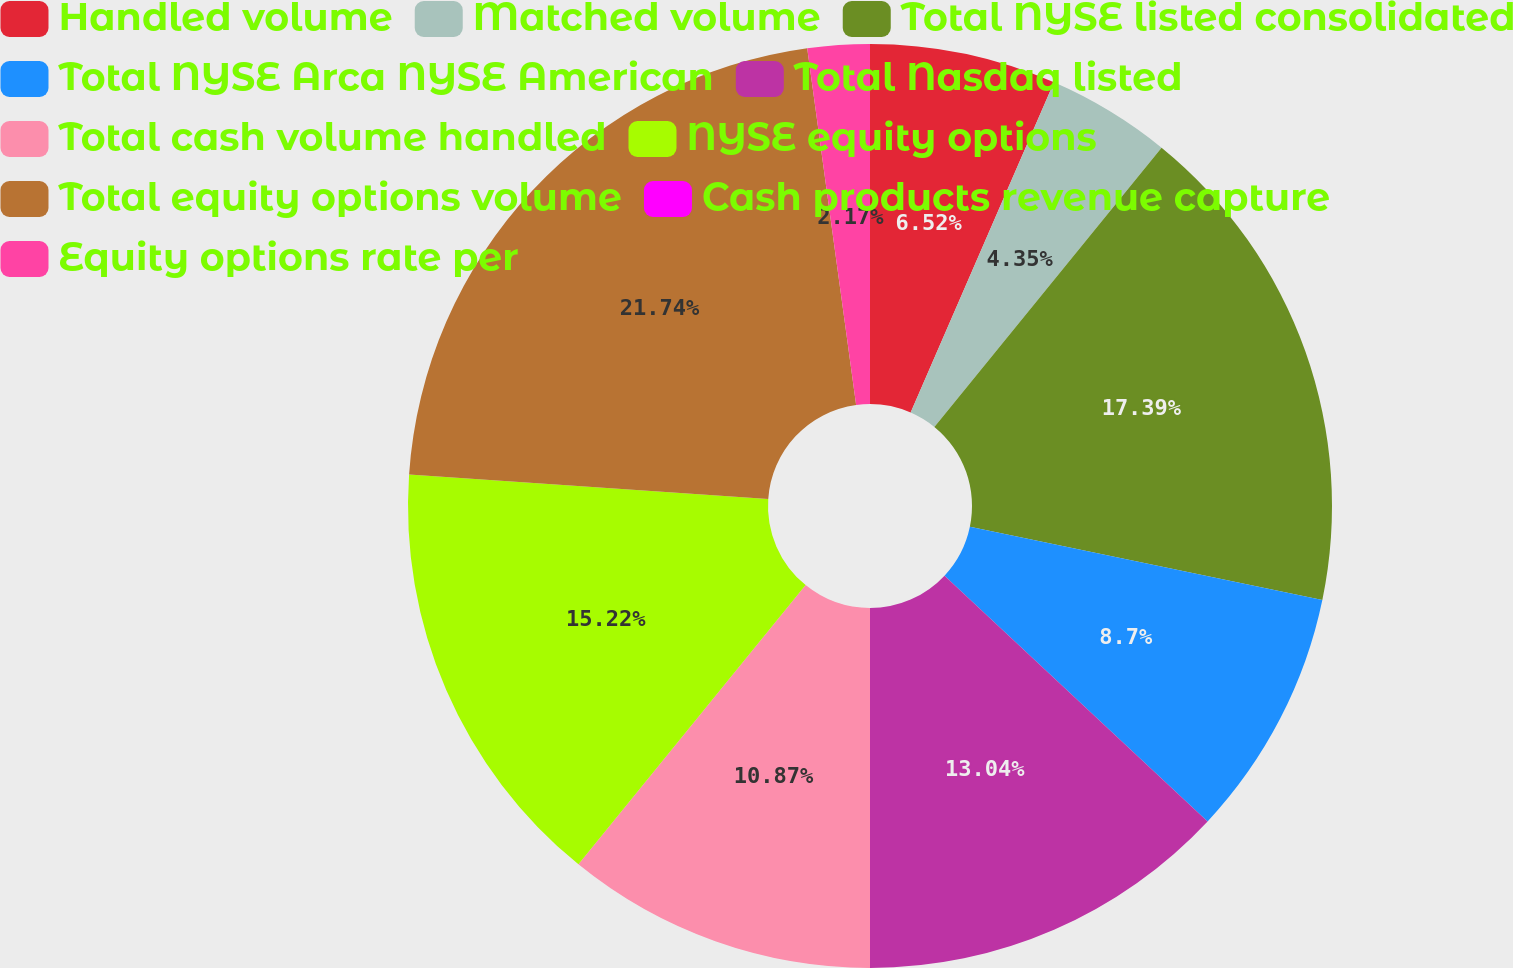Convert chart. <chart><loc_0><loc_0><loc_500><loc_500><pie_chart><fcel>Handled volume<fcel>Matched volume<fcel>Total NYSE listed consolidated<fcel>Total NYSE Arca NYSE American<fcel>Total Nasdaq listed<fcel>Total cash volume handled<fcel>NYSE equity options<fcel>Total equity options volume<fcel>Cash products revenue capture<fcel>Equity options rate per<nl><fcel>6.52%<fcel>4.35%<fcel>17.39%<fcel>8.7%<fcel>13.04%<fcel>10.87%<fcel>15.22%<fcel>21.74%<fcel>0.0%<fcel>2.17%<nl></chart> 